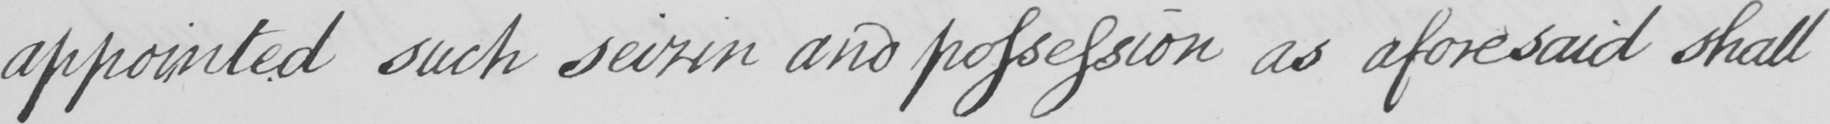Please transcribe the handwritten text in this image. appointed such seizin and possession as aforesaid shall 